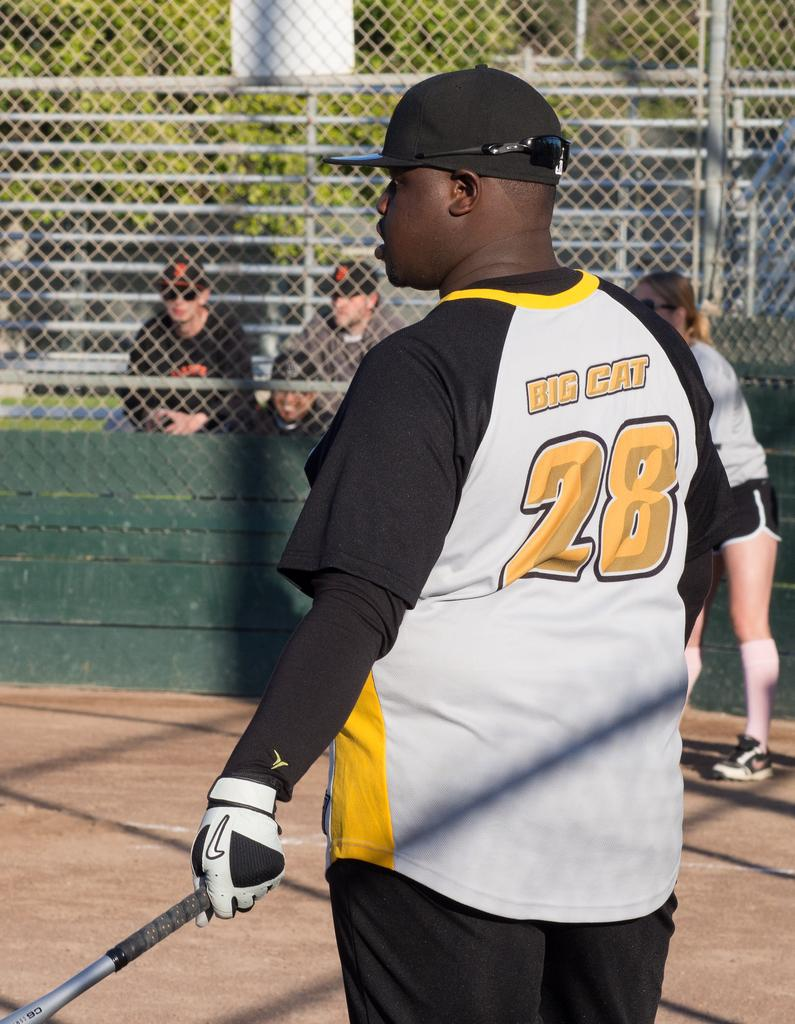Provide a one-sentence caption for the provided image. A man with a baseball bat and "Big cat" written on his back. 